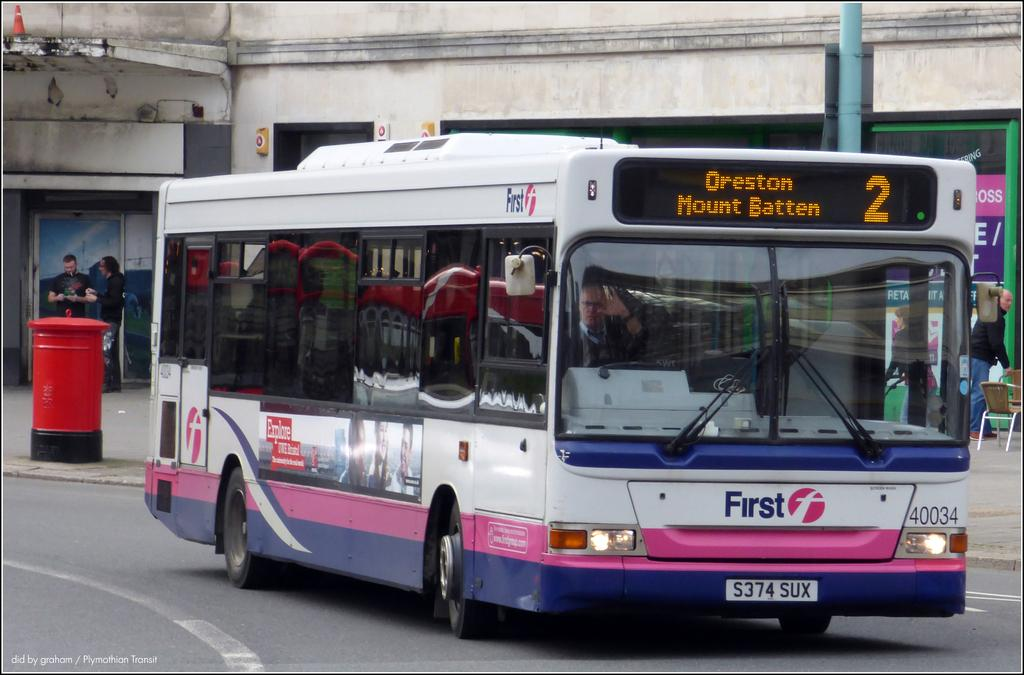<image>
Render a clear and concise summary of the photo. The number 2 bus is driving down the street. 